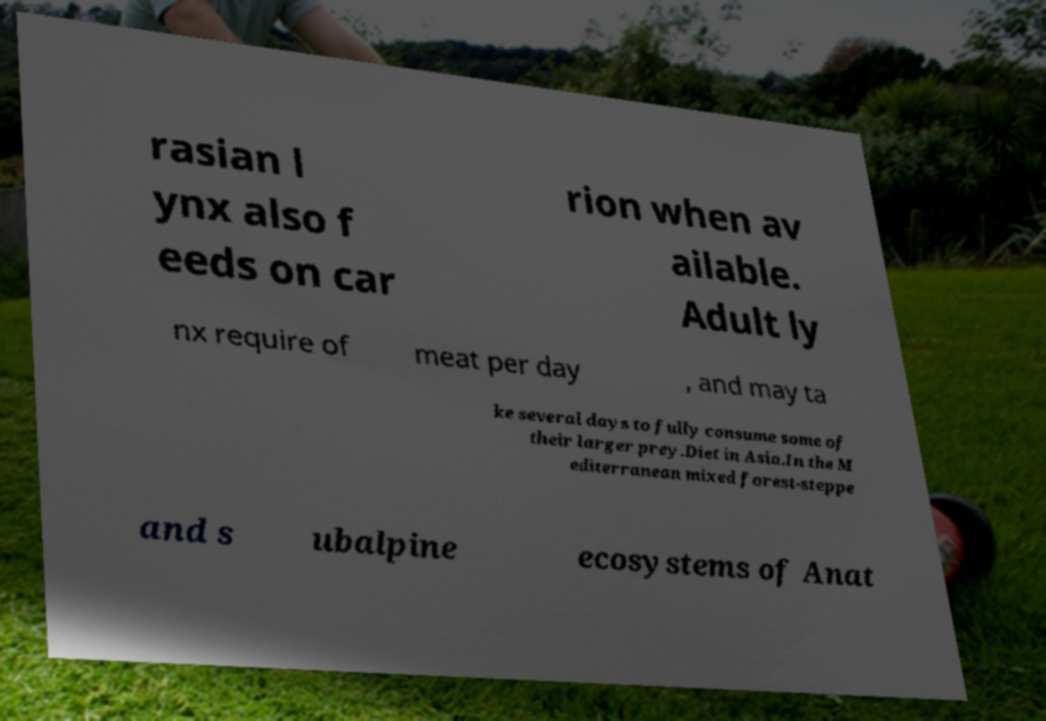Can you accurately transcribe the text from the provided image for me? rasian l ynx also f eeds on car rion when av ailable. Adult ly nx require of meat per day , and may ta ke several days to fully consume some of their larger prey.Diet in Asia.In the M editerranean mixed forest-steppe and s ubalpine ecosystems of Anat 